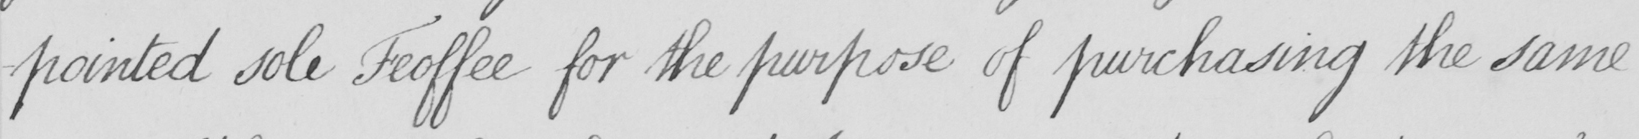What text is written in this handwritten line? -pointed sole Feoffee for the purpose of purchasing the same 